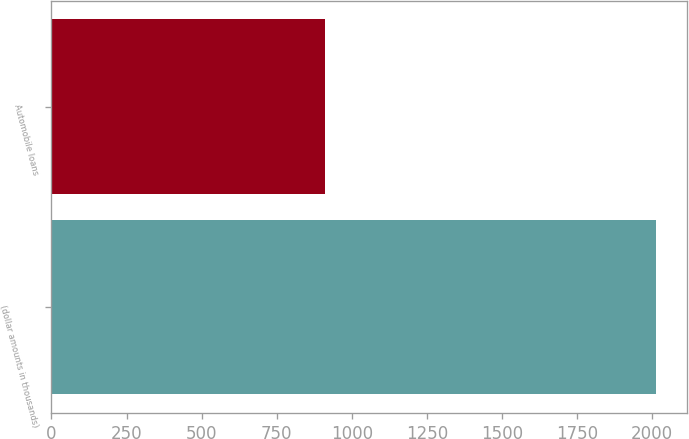<chart> <loc_0><loc_0><loc_500><loc_500><bar_chart><fcel>(dollar amounts in thousands)<fcel>Automobile loans<nl><fcel>2014<fcel>911<nl></chart> 